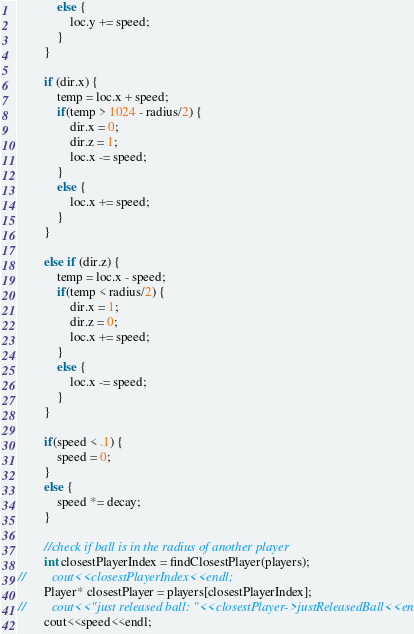<code> <loc_0><loc_0><loc_500><loc_500><_C++_>            else {
                loc.y += speed;
            }
        }

        if (dir.x) {
            temp = loc.x + speed;
            if(temp > 1024 - radius/2) {
                dir.x = 0;
                dir.z = 1;
                loc.x -= speed;
            }
            else {
                loc.x += speed;
            }
        }
        
        else if (dir.z) {
            temp = loc.x - speed;
            if(temp < radius/2) {
                dir.x = 1;
                dir.z = 0;
                loc.x += speed;
            }
            else {
                loc.x -= speed;
            }
        }
        
        if(speed < .1) {
            speed = 0;
        }
        else {
            speed *= decay;
        }
    
        //check if ball is in the radius of another player
        int closestPlayerIndex = findClosestPlayer(players);
//        cout<<closestPlayerIndex<<endl;
        Player* closestPlayer = players[closestPlayerIndex];
//        cout<<"just released ball: "<<closestPlayer->justReleasedBall<<endl;
        cout<<speed<<endl;</code> 